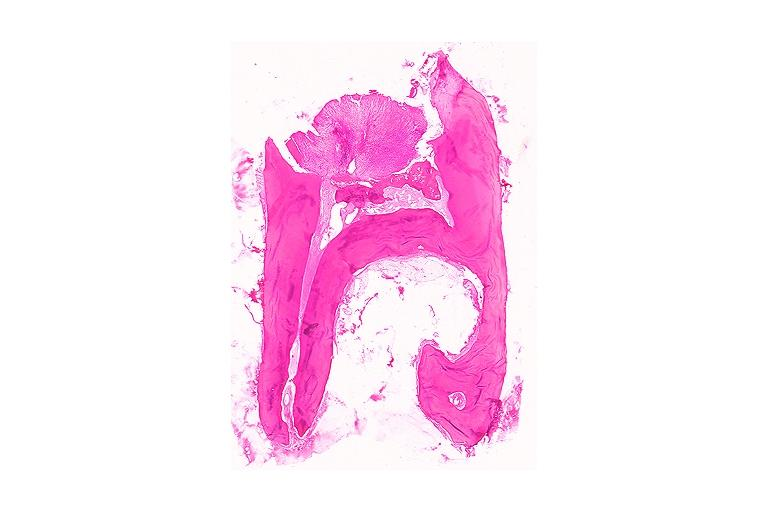what is present?
Answer the question using a single word or phrase. Oral 